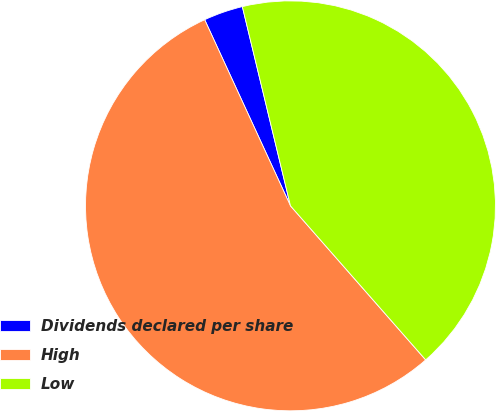Convert chart. <chart><loc_0><loc_0><loc_500><loc_500><pie_chart><fcel>Dividends declared per share<fcel>High<fcel>Low<nl><fcel>3.1%<fcel>54.59%<fcel>42.31%<nl></chart> 